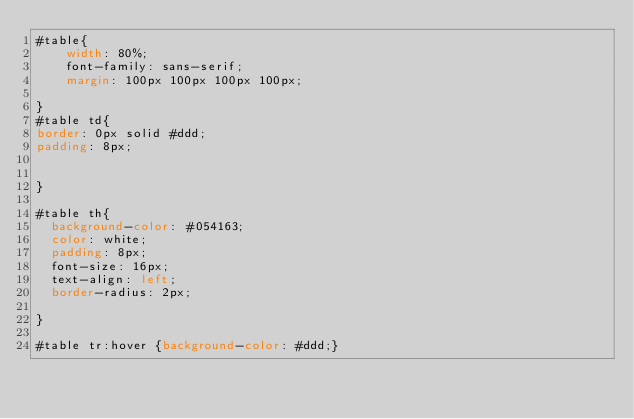Convert code to text. <code><loc_0><loc_0><loc_500><loc_500><_CSS_>#table{
	width: 80%;
	font-family: sans-serif;
	margin: 100px 100px 100px 100px;

}
#table td{
border: 0px solid #ddd;
padding: 8px;


}

#table th{
  background-color: #054163;
  color: white;
  padding: 8px;
  font-size: 16px;
  text-align: left;
  border-radius: 2px;

}

#table tr:hover {background-color: #ddd;}</code> 